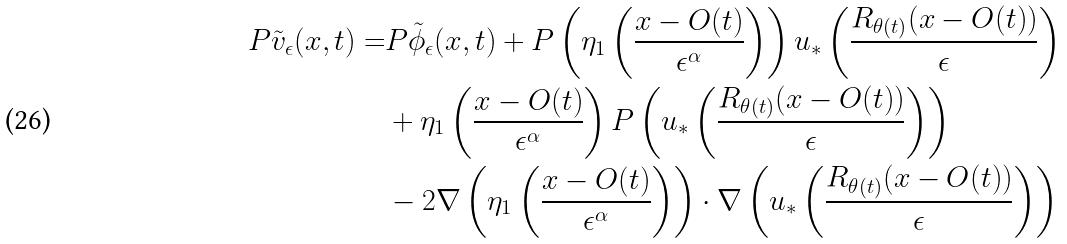<formula> <loc_0><loc_0><loc_500><loc_500>P \tilde { v } _ { \epsilon } ( x , t ) = & P \tilde { \phi } _ { \epsilon } ( x , t ) + P \left ( \eta _ { 1 } \left ( \frac { x - O ( t ) } { \epsilon ^ { \alpha } } \right ) \right ) u _ { * } \left ( \frac { R _ { \theta ( t ) } ( x - O ( t ) ) } { \epsilon } \right ) \\ & + \eta _ { 1 } \left ( \frac { x - O ( t ) } { \epsilon ^ { \alpha } } \right ) P \left ( u _ { * } \left ( \frac { R _ { \theta ( t ) } ( x - O ( t ) ) } { \epsilon } \right ) \right ) \\ & - 2 \nabla \left ( \eta _ { 1 } \left ( \frac { x - O ( t ) } { \epsilon ^ { \alpha } } \right ) \right ) \cdot \nabla \left ( u _ { * } \left ( \frac { R _ { \theta ( t ) } ( x - O ( t ) ) } { \epsilon } \right ) \right )</formula> 